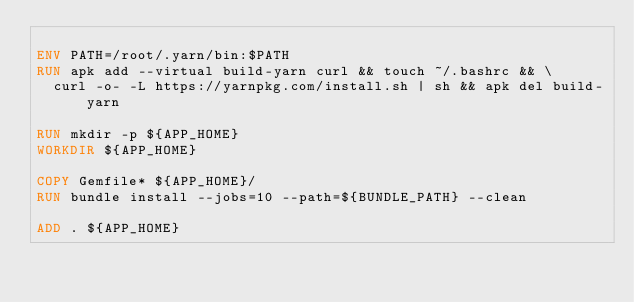<code> <loc_0><loc_0><loc_500><loc_500><_Dockerfile_>
ENV PATH=/root/.yarn/bin:$PATH
RUN apk add --virtual build-yarn curl && touch ~/.bashrc && \
  curl -o- -L https://yarnpkg.com/install.sh | sh && apk del build-yarn

RUN mkdir -p ${APP_HOME}
WORKDIR ${APP_HOME}

COPY Gemfile* ${APP_HOME}/
RUN bundle install --jobs=10 --path=${BUNDLE_PATH} --clean

ADD . ${APP_HOME}</code> 